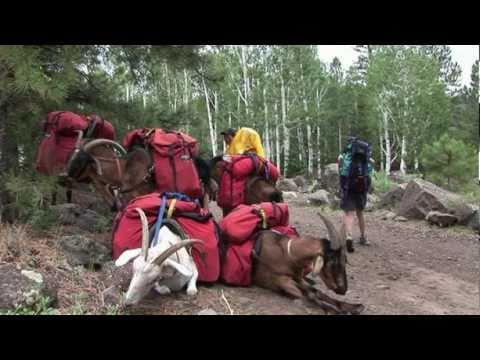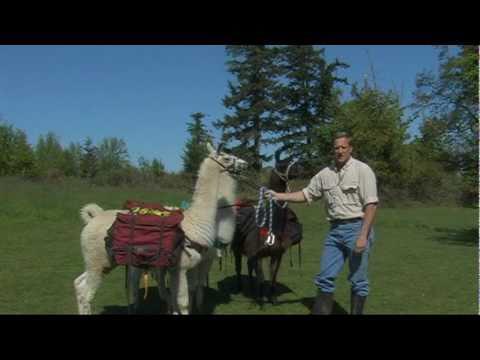The first image is the image on the left, the second image is the image on the right. Considering the images on both sides, is "An image shows a back-turned standing person on the right pulling a rope attached to a llama in front of an open wheeled hauler." valid? Answer yes or no. No. The first image is the image on the left, the second image is the image on the right. Assess this claim about the two images: "In at least one image there is a man leading a llama away from the back of a vehicle.". Correct or not? Answer yes or no. No. 